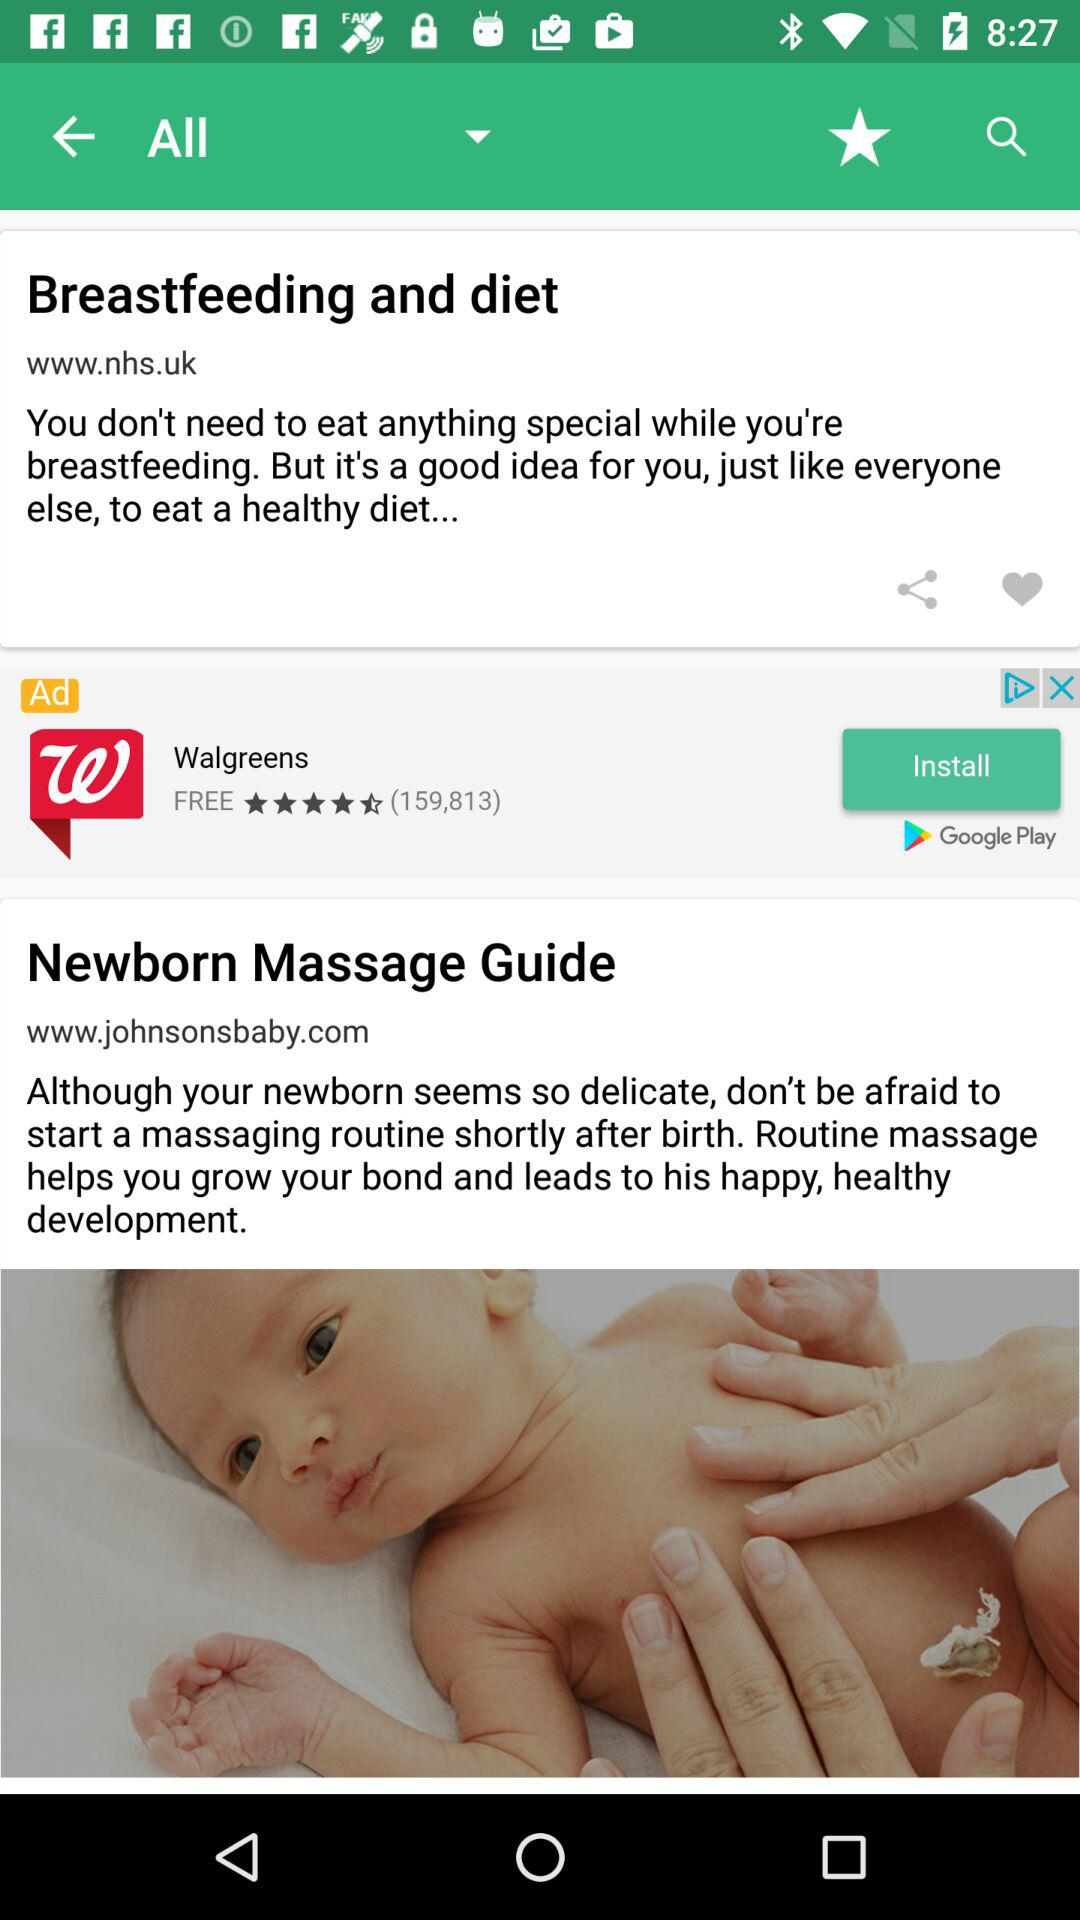Which site posted the "Newborn Massage Guide"? The site that posted the "Newborn Massage Guide" is www.johnsonsbaby.com. 